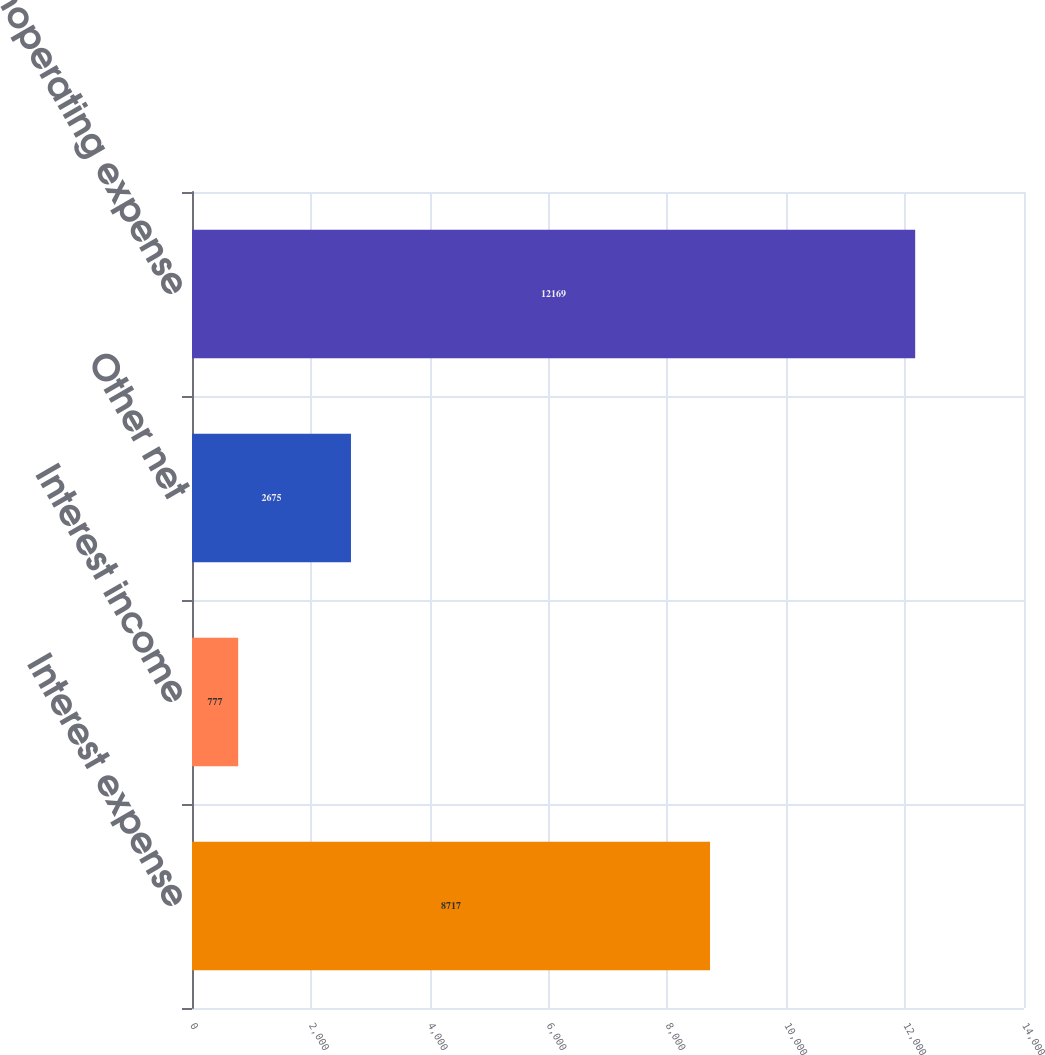<chart> <loc_0><loc_0><loc_500><loc_500><bar_chart><fcel>Interest expense<fcel>Interest income<fcel>Other net<fcel>Total nonoperating expense<nl><fcel>8717<fcel>777<fcel>2675<fcel>12169<nl></chart> 